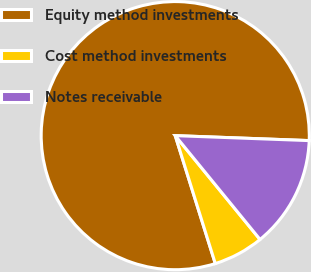Convert chart to OTSL. <chart><loc_0><loc_0><loc_500><loc_500><pie_chart><fcel>Equity method investments<fcel>Cost method investments<fcel>Notes receivable<nl><fcel>80.42%<fcel>6.07%<fcel>13.51%<nl></chart> 